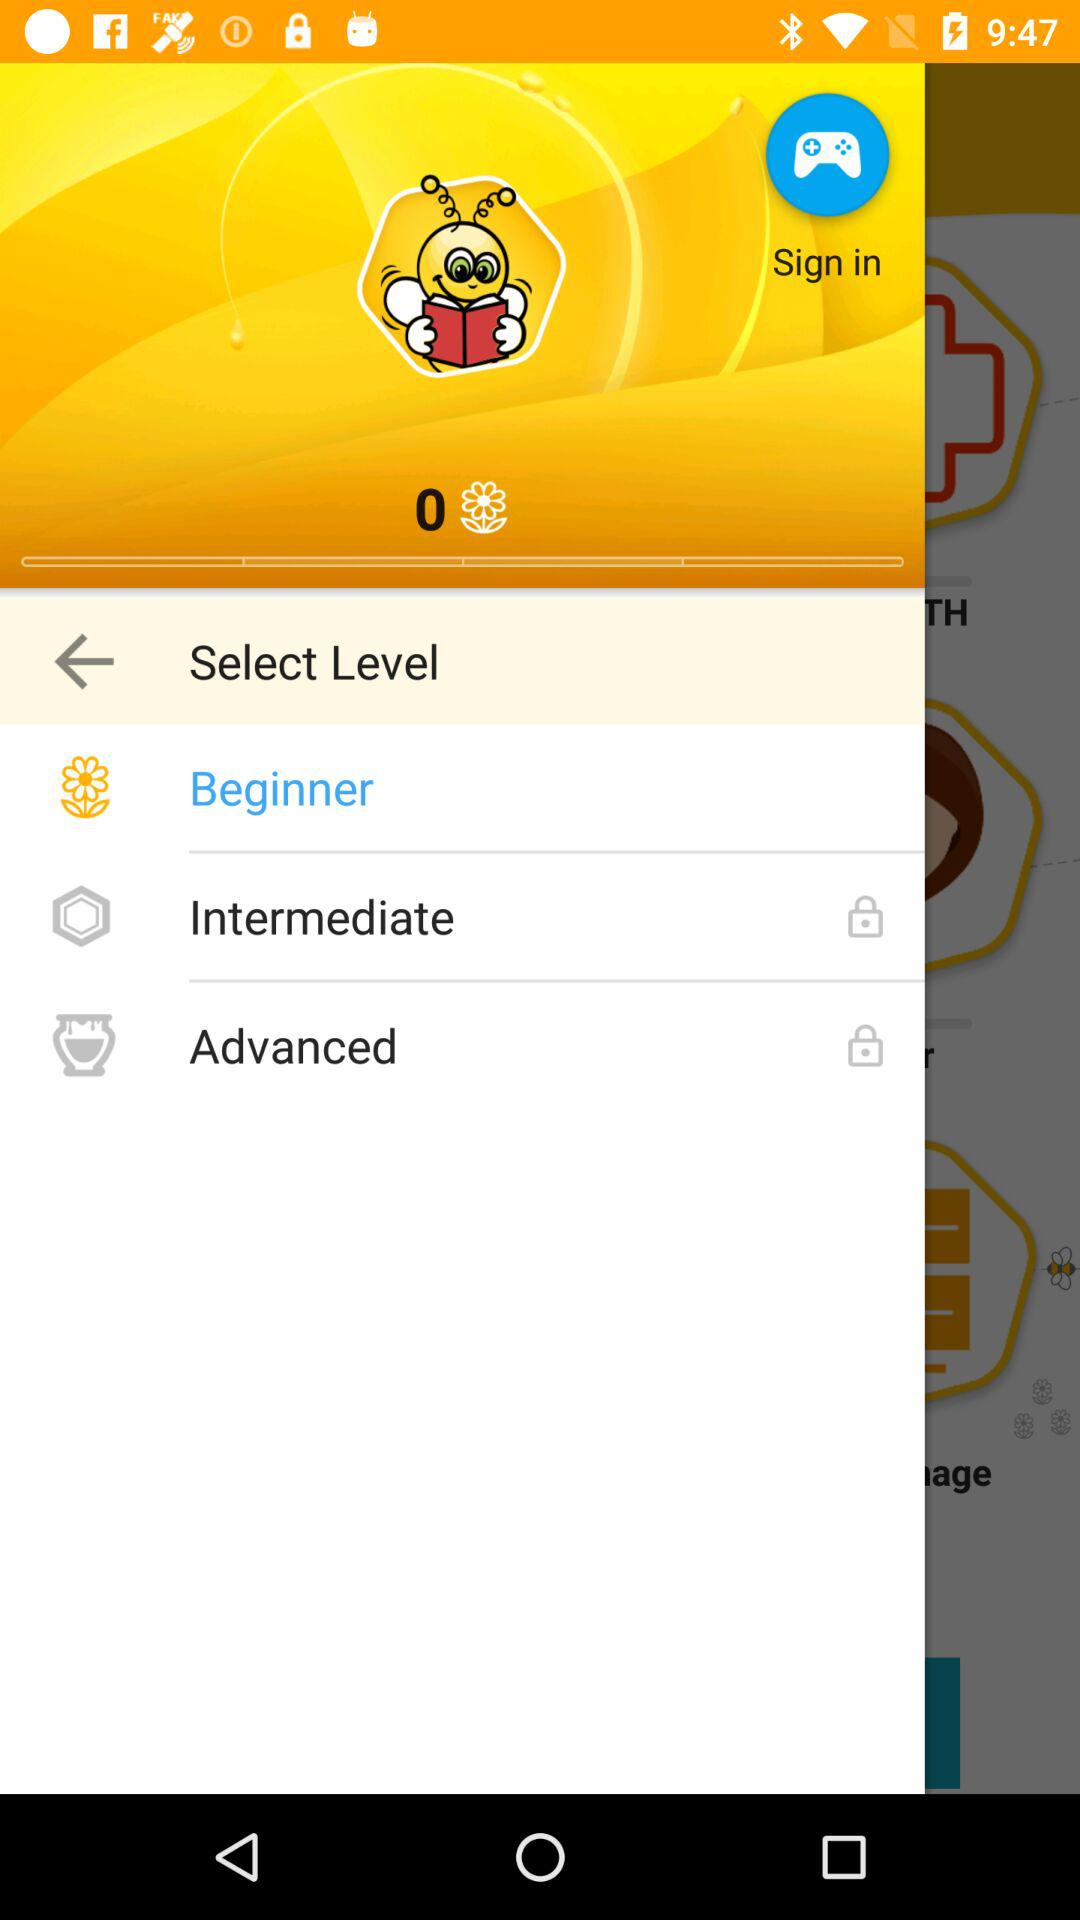How many levels are there?
Answer the question using a single word or phrase. 3 